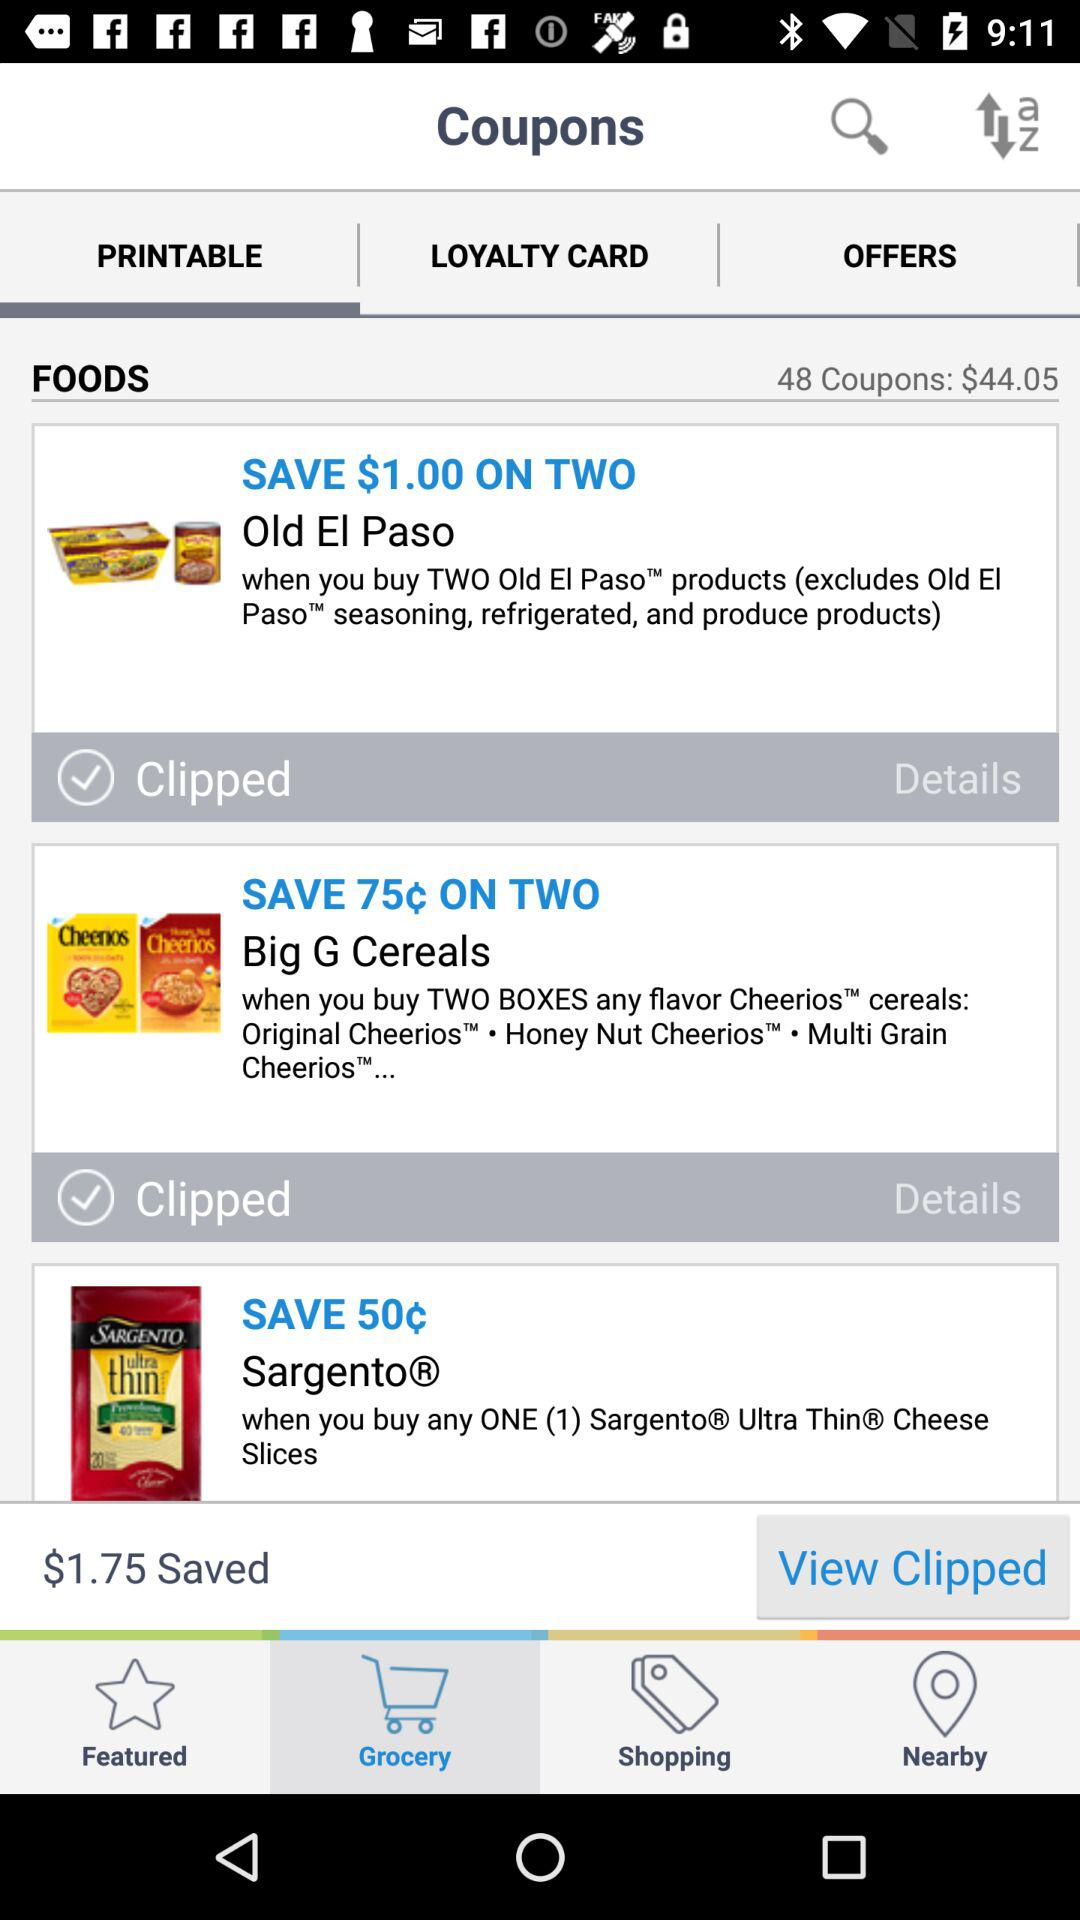How much can we save on buying Sargento? You can save 50¢ on buying Sargento. 